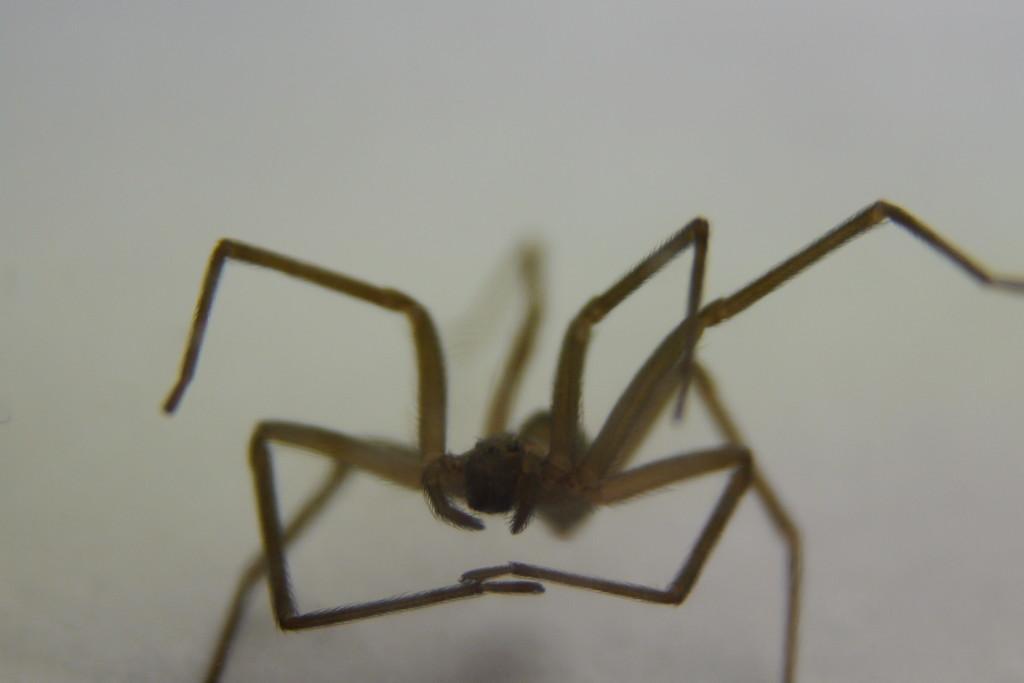Could you give a brief overview of what you see in this image? In this image we can see a spider. There is a white background. 